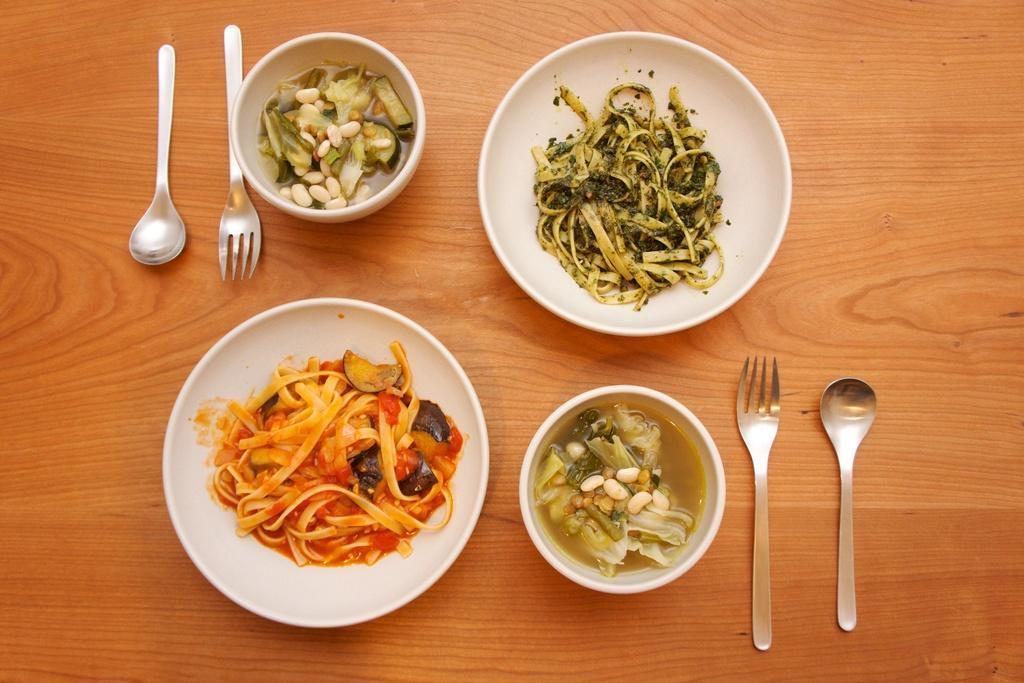Describe this image in one or two sentences. In this picture I can see food items on the plates and in the bowels, there are forks and spoons on the table. 